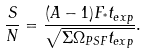Convert formula to latex. <formula><loc_0><loc_0><loc_500><loc_500>\frac { S } { N } = \frac { ( A - 1 ) F _ { ^ { * } } t _ { e x p } } { \sqrt { \Sigma \Omega _ { P S F } t _ { e x p } } } .</formula> 